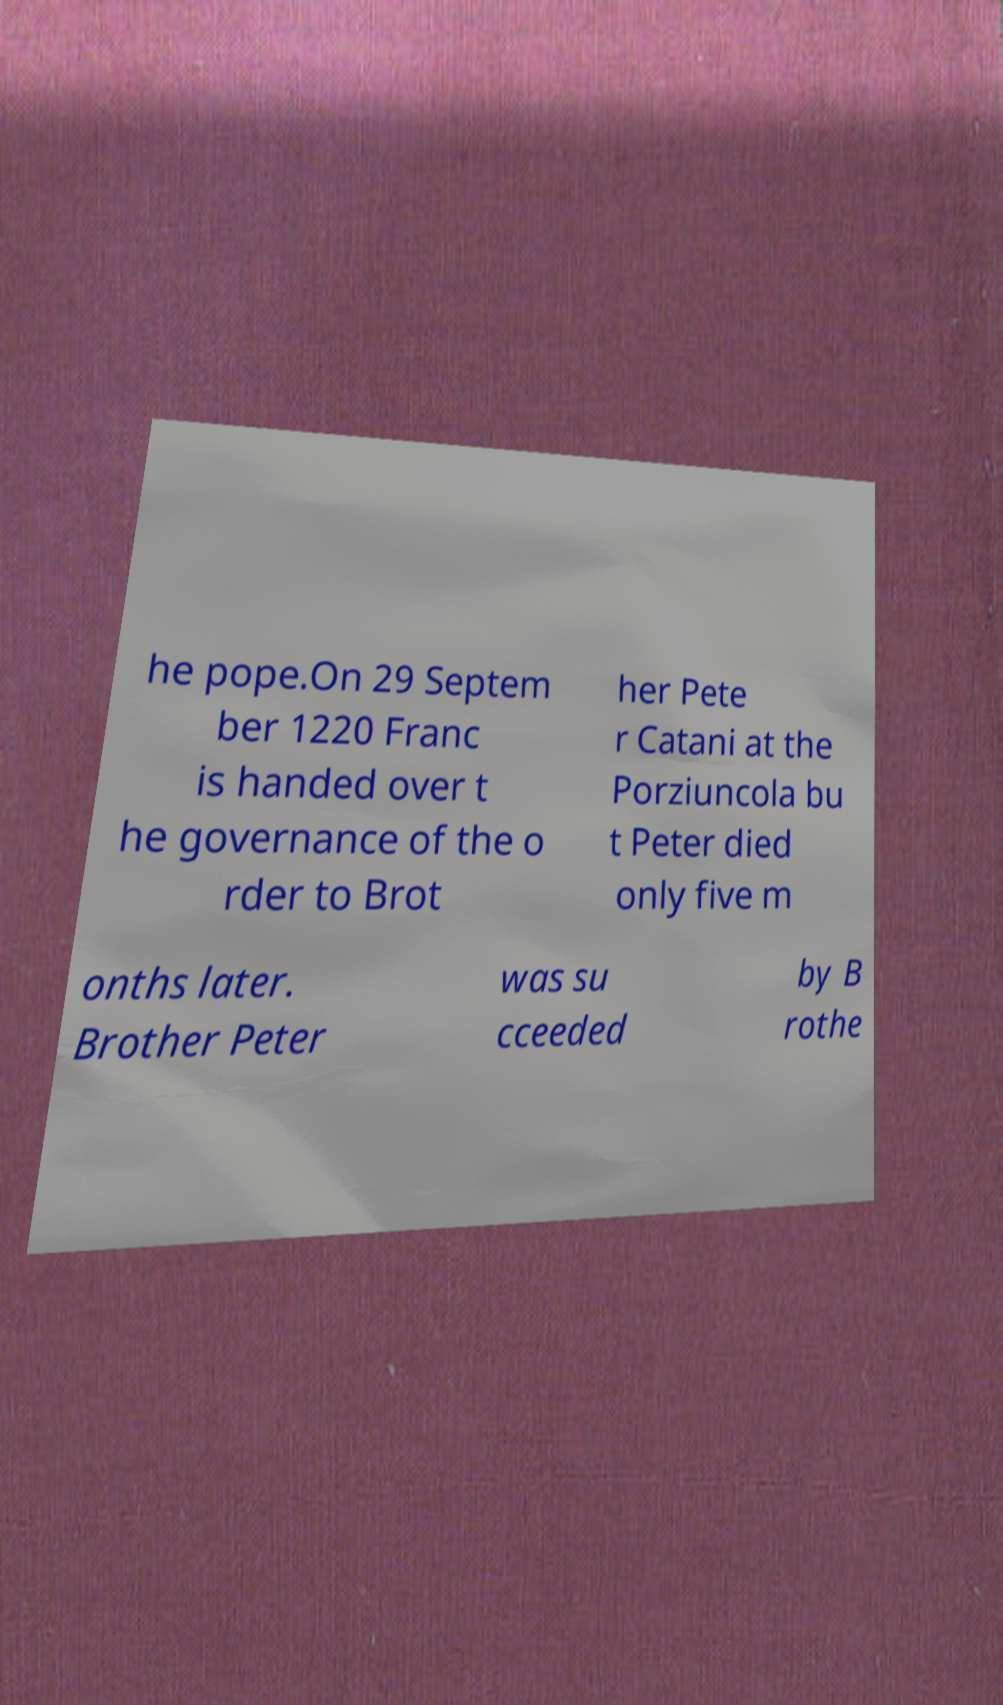There's text embedded in this image that I need extracted. Can you transcribe it verbatim? he pope.On 29 Septem ber 1220 Franc is handed over t he governance of the o rder to Brot her Pete r Catani at the Porziuncola bu t Peter died only five m onths later. Brother Peter was su cceeded by B rothe 